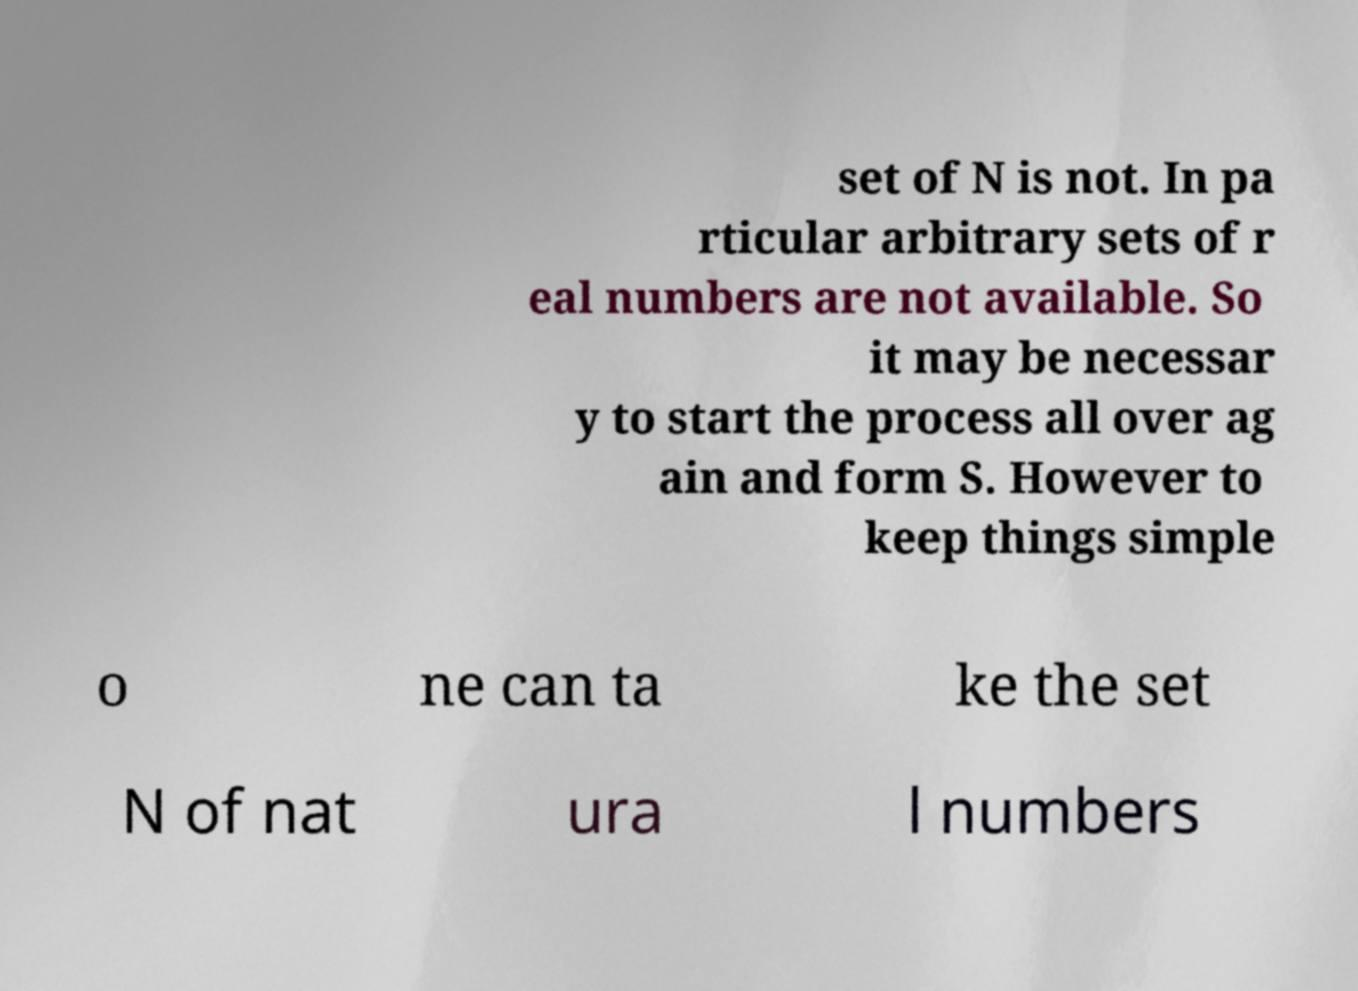For documentation purposes, I need the text within this image transcribed. Could you provide that? set of N is not. In pa rticular arbitrary sets of r eal numbers are not available. So it may be necessar y to start the process all over ag ain and form S. However to keep things simple o ne can ta ke the set N of nat ura l numbers 